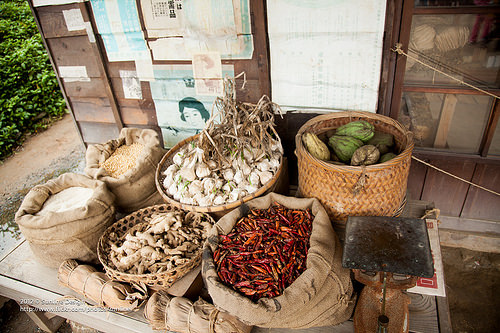<image>
Is there a bag next to the basket? Yes. The bag is positioned adjacent to the basket, located nearby in the same general area. Where is the chilis in relation to the garlic? Is it in front of the garlic? Yes. The chilis is positioned in front of the garlic, appearing closer to the camera viewpoint. 